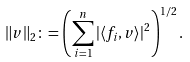<formula> <loc_0><loc_0><loc_500><loc_500>\| v \| _ { 2 } \colon = \left ( \sum _ { i = 1 } ^ { n } | \langle f _ { i } , v \rangle | ^ { 2 } \right ) ^ { 1 / 2 } .</formula> 